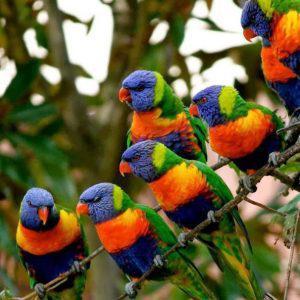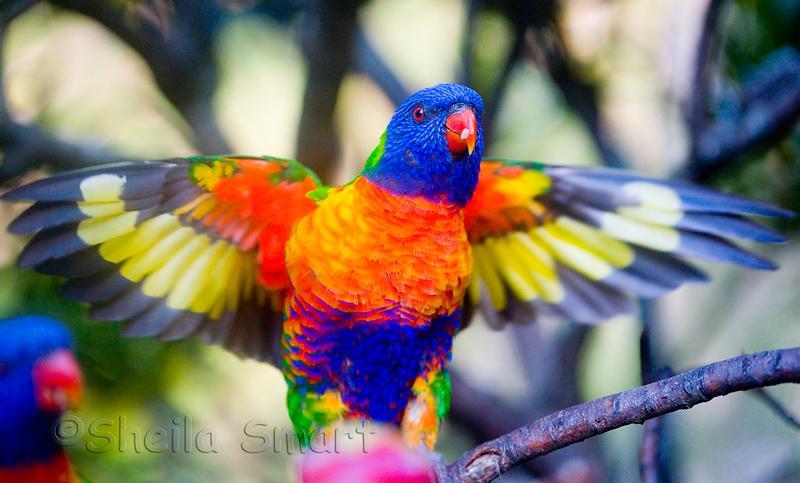The first image is the image on the left, the second image is the image on the right. Examine the images to the left and right. Is the description "Exactly four parrots are shown, one pair of similar coloring in each image, with one pair in or near vegetation." accurate? Answer yes or no. No. The first image is the image on the left, the second image is the image on the right. Considering the images on both sides, is "Four colorful birds are perched outside." valid? Answer yes or no. No. 